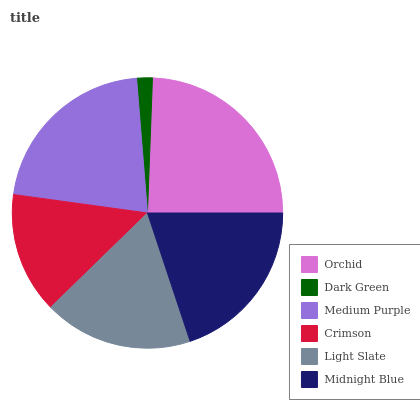Is Dark Green the minimum?
Answer yes or no. Yes. Is Orchid the maximum?
Answer yes or no. Yes. Is Medium Purple the minimum?
Answer yes or no. No. Is Medium Purple the maximum?
Answer yes or no. No. Is Medium Purple greater than Dark Green?
Answer yes or no. Yes. Is Dark Green less than Medium Purple?
Answer yes or no. Yes. Is Dark Green greater than Medium Purple?
Answer yes or no. No. Is Medium Purple less than Dark Green?
Answer yes or no. No. Is Midnight Blue the high median?
Answer yes or no. Yes. Is Light Slate the low median?
Answer yes or no. Yes. Is Crimson the high median?
Answer yes or no. No. Is Midnight Blue the low median?
Answer yes or no. No. 